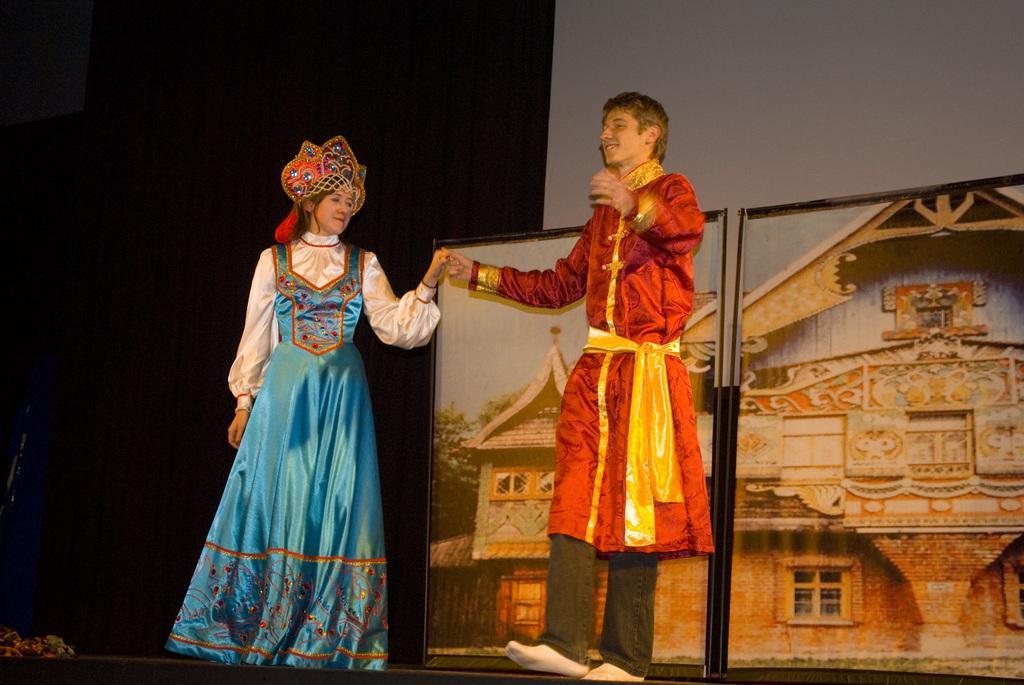Could you give a brief overview of what you see in this image? In this image I can see two persons are standing in the front and I can see both of them are wearing costumes. In the background I can see few frames and on the bottom left corner of this image I can see an object. 